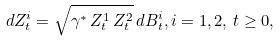Convert formula to latex. <formula><loc_0><loc_0><loc_500><loc_500>d Z ^ { i } _ { t } = \sqrt { \gamma ^ { * } \, Z ^ { 1 } _ { t } \, Z ^ { 2 } _ { t } } \, d B _ { t } ^ { i } , i = 1 , 2 , \, t \geq 0 ,</formula> 